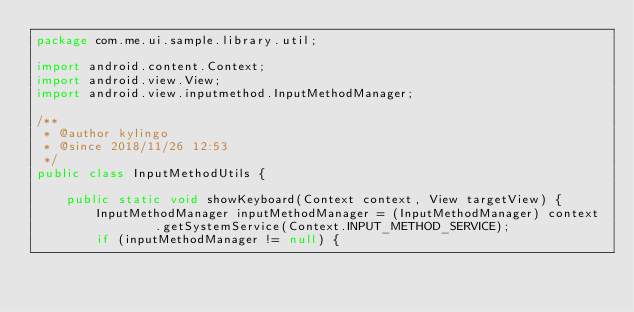Convert code to text. <code><loc_0><loc_0><loc_500><loc_500><_Java_>package com.me.ui.sample.library.util;

import android.content.Context;
import android.view.View;
import android.view.inputmethod.InputMethodManager;

/**
 * @author kylingo
 * @since 2018/11/26 12:53
 */
public class InputMethodUtils {

    public static void showKeyboard(Context context, View targetView) {
        InputMethodManager inputMethodManager = (InputMethodManager) context
                .getSystemService(Context.INPUT_METHOD_SERVICE);
        if (inputMethodManager != null) {</code> 